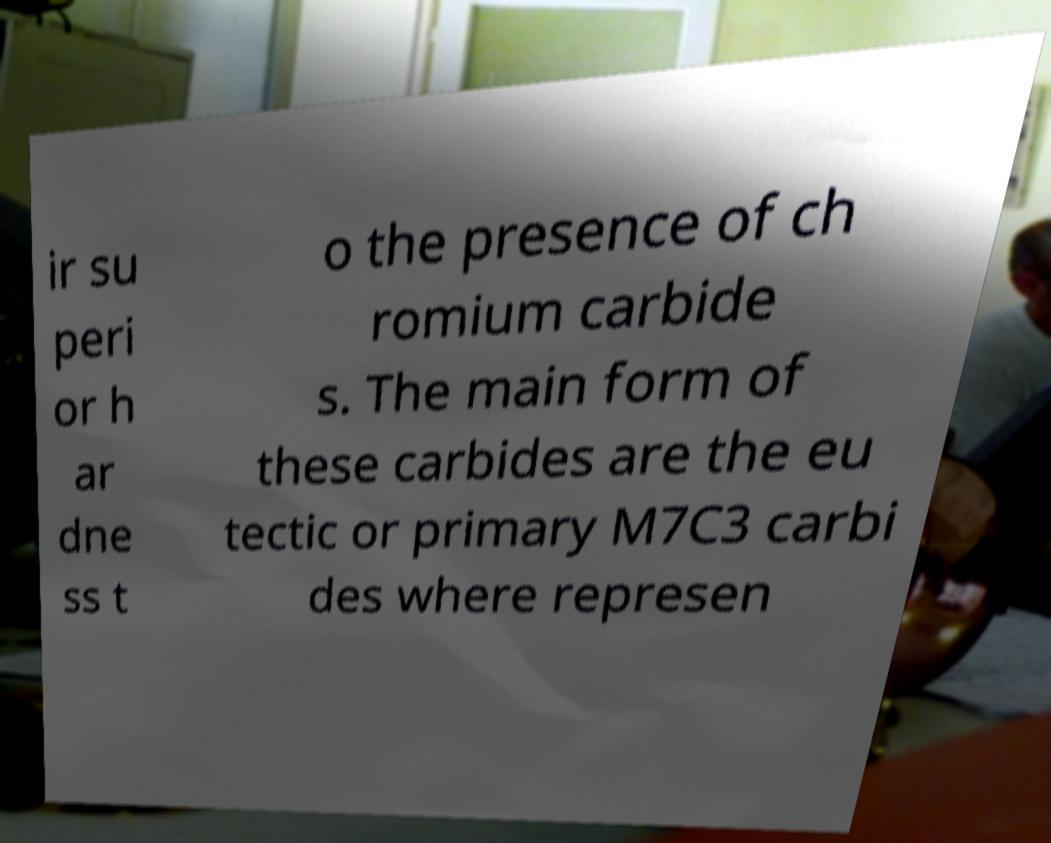Can you accurately transcribe the text from the provided image for me? ir su peri or h ar dne ss t o the presence of ch romium carbide s. The main form of these carbides are the eu tectic or primary M7C3 carbi des where represen 